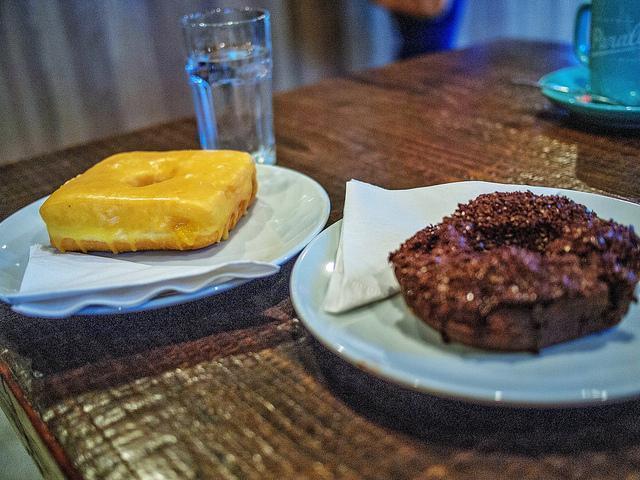How many glasses are there?
Give a very brief answer. 1. How many cups can you see?
Give a very brief answer. 2. How many donuts are there?
Give a very brief answer. 2. How many umbrellas are in the photo?
Give a very brief answer. 0. 